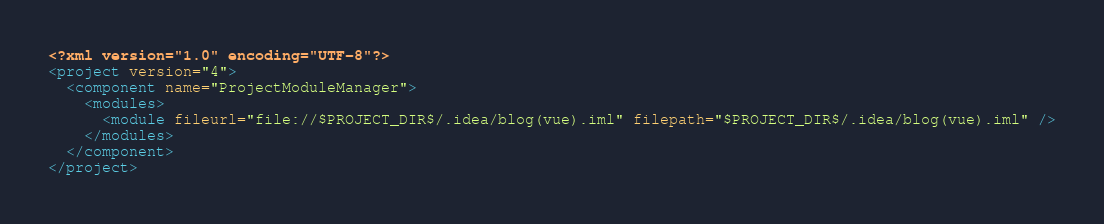<code> <loc_0><loc_0><loc_500><loc_500><_XML_><?xml version="1.0" encoding="UTF-8"?>
<project version="4">
  <component name="ProjectModuleManager">
    <modules>
      <module fileurl="file://$PROJECT_DIR$/.idea/blog(vue).iml" filepath="$PROJECT_DIR$/.idea/blog(vue).iml" />
    </modules>
  </component>
</project></code> 